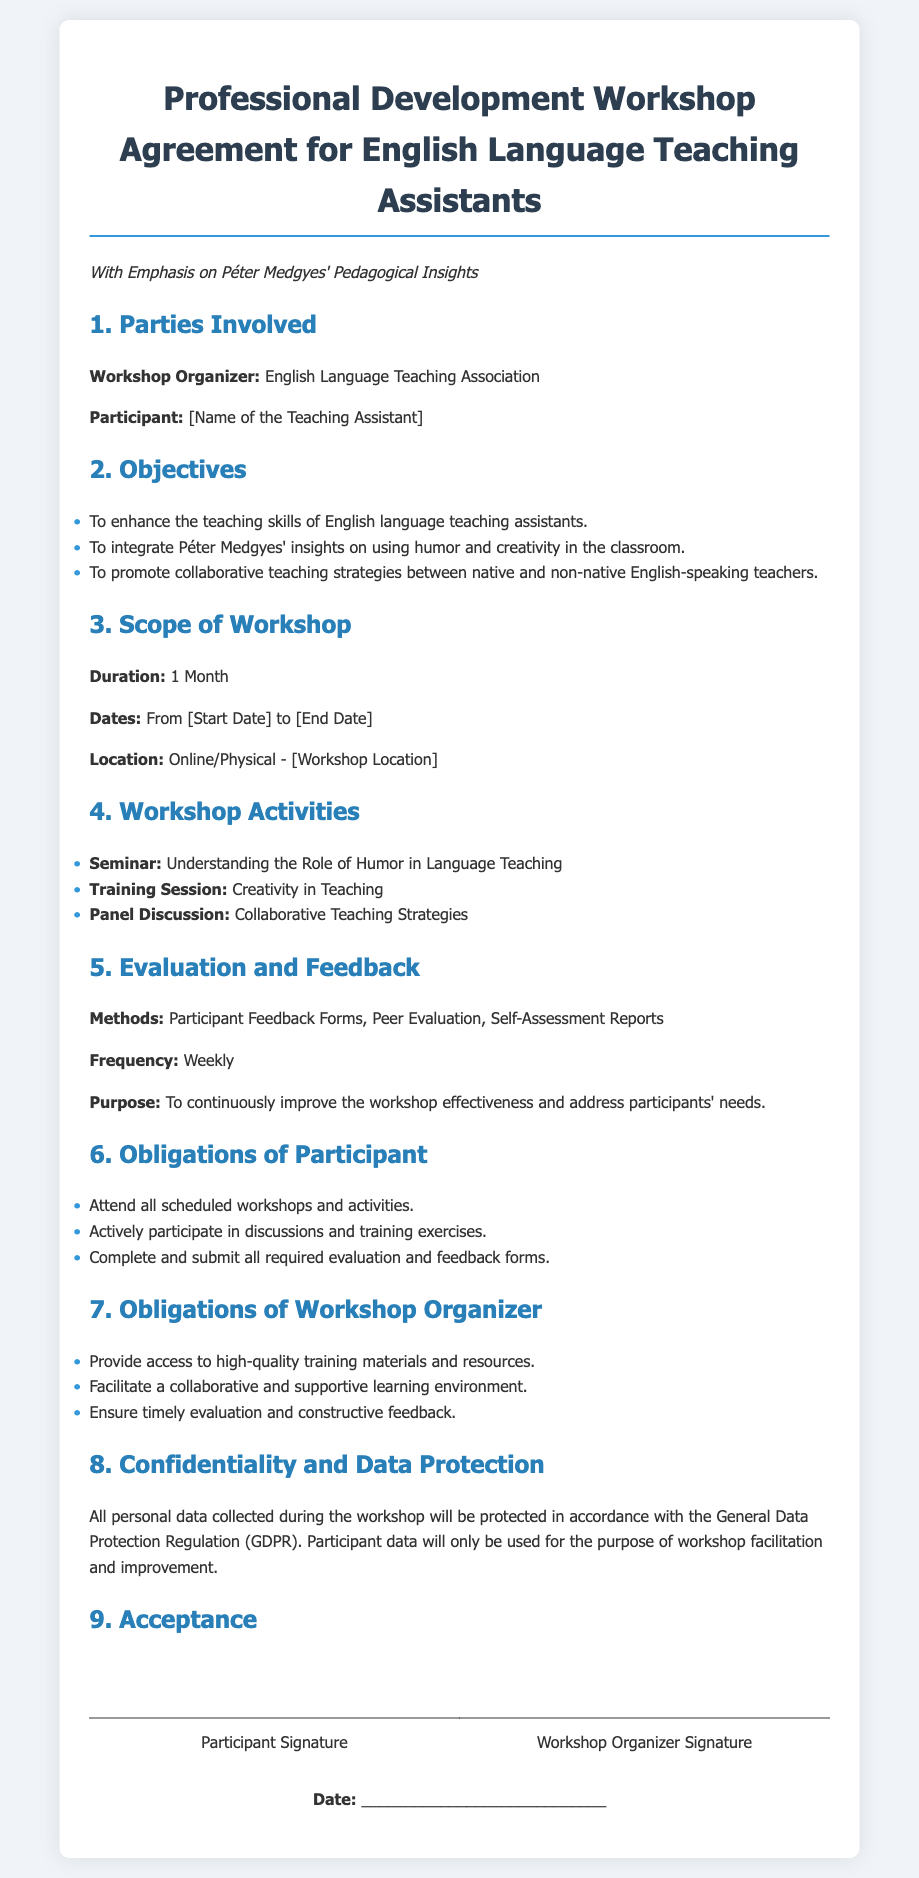what is the title of the document? The title is prominently displayed at the top of the document, indicating the purpose of the content.
Answer: Professional Development Workshop Agreement for English Language Teaching Assistants who is the workshop organizer? The organizer's name is mentioned in the parties involved section, indicating who is responsible for hosting the workshop.
Answer: English Language Teaching Association what are the workshop dates? The dates are identified in the scope of the workshop section, specifying the period during which the workshop will occur.
Answer: From [Start Date] to [End Date] how long is the workshop scheduled to last? The duration of the workshop is explicitly stated, providing a clear timeframe for the event.
Answer: 1 Month what is one of the objectives of the workshop? Objectives are listed to highlight the goals of the workshop, providing insight into its intended outcomes.
Answer: To enhance the teaching skills of English language teaching assistants what method is used for evaluation and feedback? The document specifies methods in the evaluation and feedback section, showing how the effectiveness of the workshop will be assessed.
Answer: Participant Feedback Forms what is the obligation of the workshop organizer? Obligations are outlined in a specific section, detailing responsibilities of the workshop organizer to ensure a successful workshop.
Answer: Provide access to high-quality training materials and resources how will participant data be protected? The confidentiality and data protection section addresses the measures in place to handle personal data, ensuring privacy compliance.
Answer: In accordance with the General Data Protection Regulation (GDPR) 